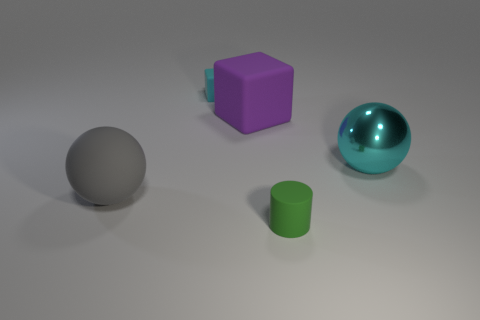Add 3 green balls. How many objects exist? 8 Subtract all spheres. How many objects are left? 3 Subtract all cyan metallic objects. Subtract all big green blocks. How many objects are left? 4 Add 2 tiny matte cubes. How many tiny matte cubes are left? 3 Add 4 large purple matte objects. How many large purple matte objects exist? 5 Subtract 1 gray balls. How many objects are left? 4 